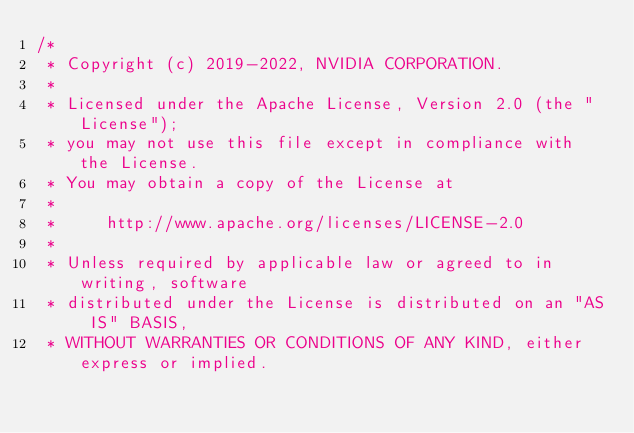<code> <loc_0><loc_0><loc_500><loc_500><_Cuda_>/*
 * Copyright (c) 2019-2022, NVIDIA CORPORATION.
 *
 * Licensed under the Apache License, Version 2.0 (the "License");
 * you may not use this file except in compliance with the License.
 * You may obtain a copy of the License at
 *
 *     http://www.apache.org/licenses/LICENSE-2.0
 *
 * Unless required by applicable law or agreed to in writing, software
 * distributed under the License is distributed on an "AS IS" BASIS,
 * WITHOUT WARRANTIES OR CONDITIONS OF ANY KIND, either express or implied.</code> 